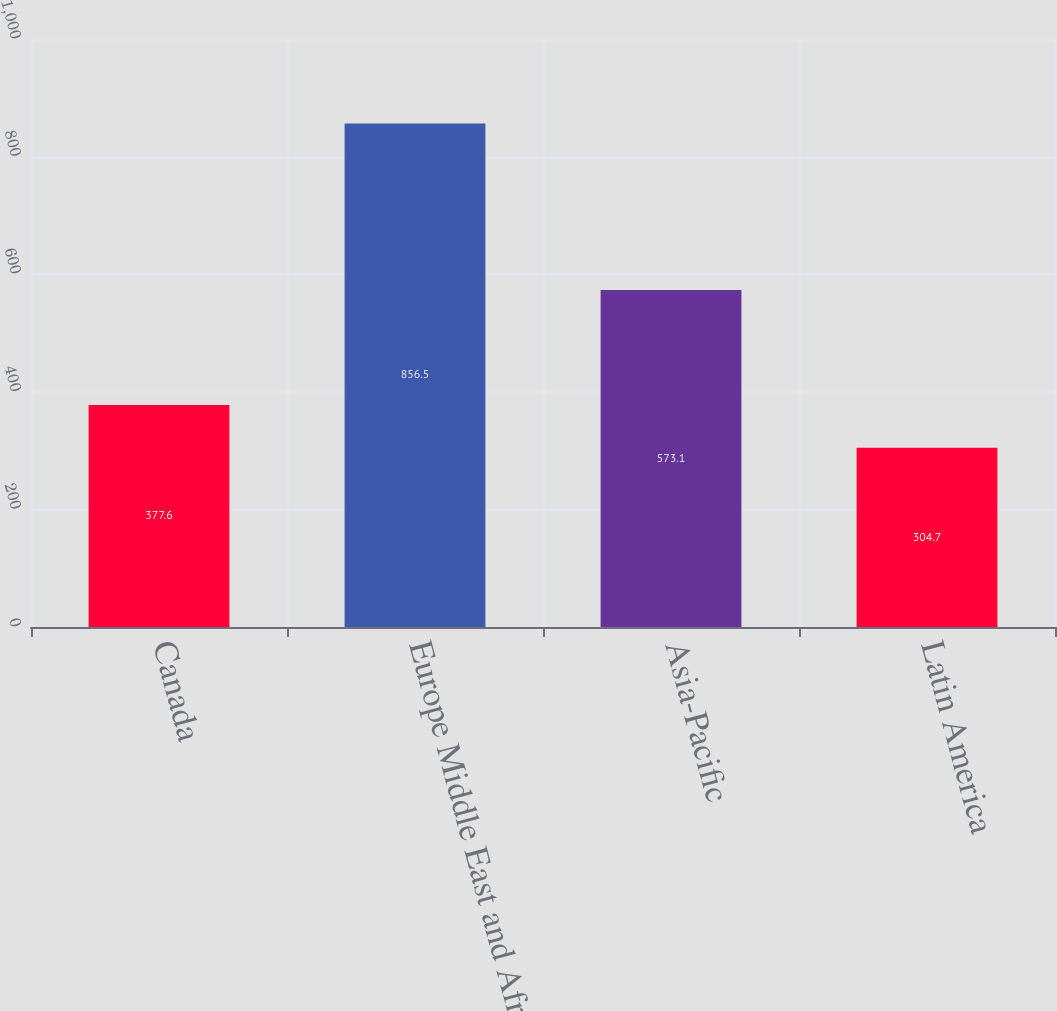Convert chart. <chart><loc_0><loc_0><loc_500><loc_500><bar_chart><fcel>Canada<fcel>Europe Middle East and Africa<fcel>Asia-Pacific<fcel>Latin America<nl><fcel>377.6<fcel>856.5<fcel>573.1<fcel>304.7<nl></chart> 